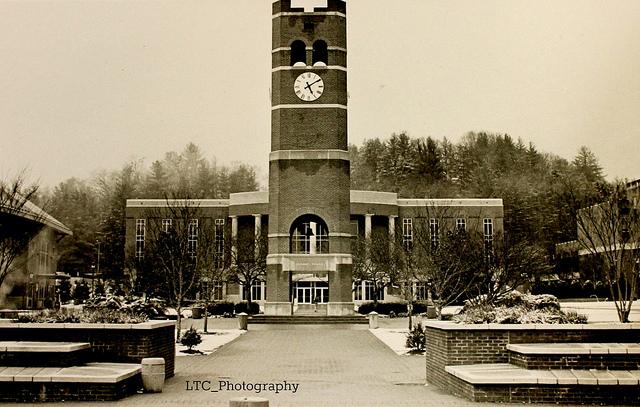What does the clock say?
Keep it brief. 5:10. Is the picture of the olden days?
Concise answer only. Yes. Is there a bell tower?
Quick response, please. Yes. 